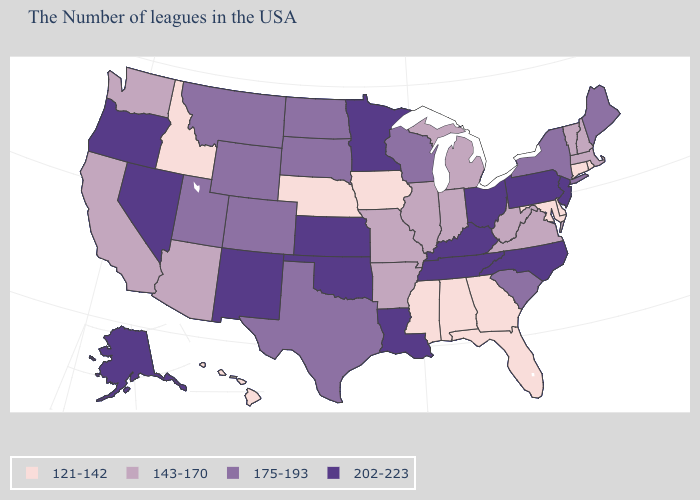Which states have the lowest value in the USA?
Quick response, please. Rhode Island, Connecticut, Delaware, Maryland, Florida, Georgia, Alabama, Mississippi, Iowa, Nebraska, Idaho, Hawaii. Does the first symbol in the legend represent the smallest category?
Give a very brief answer. Yes. Name the states that have a value in the range 121-142?
Keep it brief. Rhode Island, Connecticut, Delaware, Maryland, Florida, Georgia, Alabama, Mississippi, Iowa, Nebraska, Idaho, Hawaii. How many symbols are there in the legend?
Write a very short answer. 4. Is the legend a continuous bar?
Short answer required. No. Among the states that border Virginia , does Maryland have the highest value?
Be succinct. No. Does Rhode Island have a lower value than Oregon?
Quick response, please. Yes. What is the highest value in the USA?
Be succinct. 202-223. Name the states that have a value in the range 175-193?
Quick response, please. Maine, New York, South Carolina, Wisconsin, Texas, South Dakota, North Dakota, Wyoming, Colorado, Utah, Montana. Does Oregon have the highest value in the West?
Short answer required. Yes. Name the states that have a value in the range 175-193?
Keep it brief. Maine, New York, South Carolina, Wisconsin, Texas, South Dakota, North Dakota, Wyoming, Colorado, Utah, Montana. Does Montana have the lowest value in the USA?
Quick response, please. No. Which states hav the highest value in the South?
Keep it brief. North Carolina, Kentucky, Tennessee, Louisiana, Oklahoma. Does Nevada have the same value as New Mexico?
Give a very brief answer. Yes. Name the states that have a value in the range 202-223?
Write a very short answer. New Jersey, Pennsylvania, North Carolina, Ohio, Kentucky, Tennessee, Louisiana, Minnesota, Kansas, Oklahoma, New Mexico, Nevada, Oregon, Alaska. 